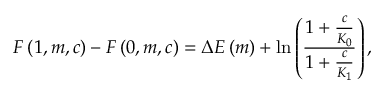<formula> <loc_0><loc_0><loc_500><loc_500>F \left ( 1 , m , c \right ) - F \left ( 0 , m , c \right ) = \Delta E \left ( m \right ) + \ln \left ( \frac { 1 + \frac { c } { K _ { 0 } } } { 1 + \frac { c } { K _ { 1 } } } \right ) ,</formula> 